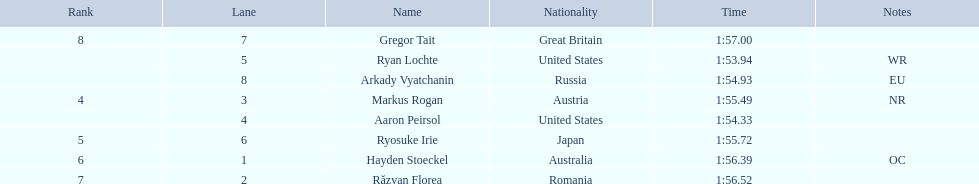Who participated in the event? Ryan Lochte, Aaron Peirsol, Arkady Vyatchanin, Markus Rogan, Ryosuke Irie, Hayden Stoeckel, Răzvan Florea, Gregor Tait. What was the finishing time of each athlete? 1:53.94, 1:54.33, 1:54.93, 1:55.49, 1:55.72, 1:56.39, 1:56.52, 1:57.00. How about just ryosuke irie? 1:55.72. 